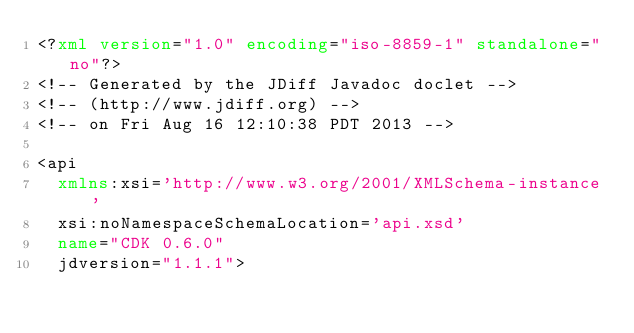Convert code to text. <code><loc_0><loc_0><loc_500><loc_500><_XML_><?xml version="1.0" encoding="iso-8859-1" standalone="no"?>
<!-- Generated by the JDiff Javadoc doclet -->
<!-- (http://www.jdiff.org) -->
<!-- on Fri Aug 16 12:10:38 PDT 2013 -->

<api
  xmlns:xsi='http://www.w3.org/2001/XMLSchema-instance'
  xsi:noNamespaceSchemaLocation='api.xsd'
  name="CDK 0.6.0"
  jdversion="1.1.1">
</code> 